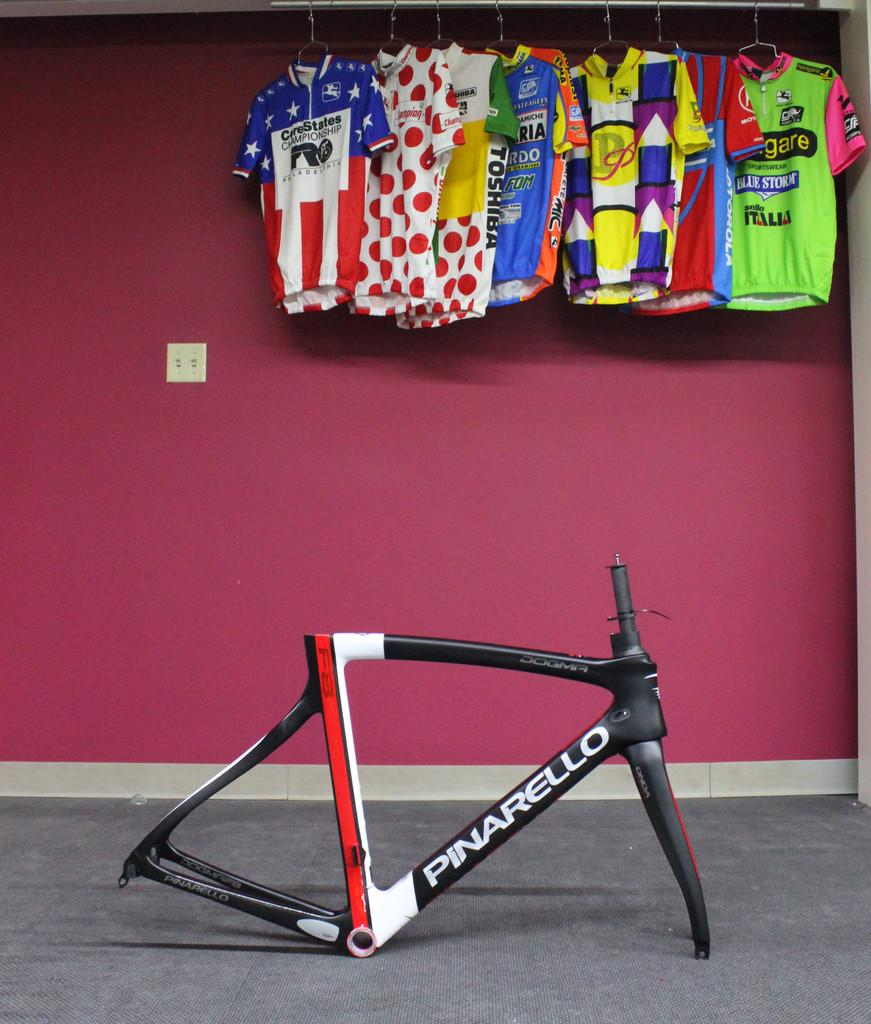<image>
Offer a succinct explanation of the picture presented. A Pinarello bicycle frame sitting on a gray carpeted floor with bicycle racing shirts hanging on a rack above it. 